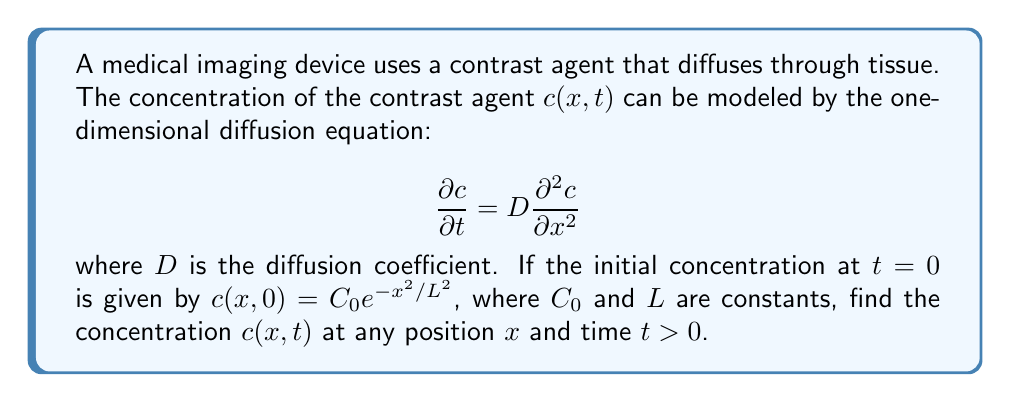Can you answer this question? To solve this problem, we'll follow these steps:

1) The general solution to the diffusion equation with an initial condition $c(x,0) = f(x)$ is:

   $$c(x,t) = \frac{1}{\sqrt{4\pi Dt}} \int_{-\infty}^{\infty} f(x') e^{-\frac{(x-x')^2}{4Dt}} dx'$$

2) In our case, $f(x) = C_0e^{-x^2/L^2}$. Substituting this into the general solution:

   $$c(x,t) = \frac{C_0}{\sqrt{4\pi Dt}} \int_{-\infty}^{\infty} e^{-x'^2/L^2} e^{-(x-x')^2/(4Dt)} dx'$$

3) To solve this integral, we need to complete the square in the exponent. Let's combine the exponents:

   $$\frac{-x'^2}{L^2} - \frac{(x-x')^2}{4Dt} = -\left(\frac{1}{L^2} + \frac{1}{4Dt}\right)x'^2 + \frac{x}{2Dt}x' - \frac{x^2}{4Dt}$$

4) Let $a = \frac{1}{L^2} + \frac{1}{4Dt}$ and $b = \frac{x}{2Dt}$. Then the exponent becomes:

   $$-ax'^2 + bx' - \frac{x^2}{4Dt} = -a\left(x'^2 - \frac{b}{a}x' + \frac{b^2}{4a^2}\right) + \frac{b^2}{4a} - \frac{x^2}{4Dt}$$

5) Substituting back and factoring out constants from the integral:

   $$c(x,t) = \frac{C_0}{\sqrt{4\pi Dt}} e^{-\frac{x^2}{4Dt}} e^{\frac{b^2}{4a}} \int_{-\infty}^{\infty} e^{-a(x'-\frac{b}{2a})^2} dx'$$

6) The integral $\int_{-\infty}^{\infty} e^{-a(x'-\frac{b}{2a})^2} dx' = \sqrt{\frac{\pi}{a}}$

7) Substituting this and simplifying:

   $$c(x,t) = \frac{C_0}{\sqrt{4\pi Dt}} e^{-\frac{x^2}{4Dt}} e^{\frac{b^2}{4a}} \sqrt{\frac{\pi}{a}} = \frac{C_0}{\sqrt{1 + 4Dt/L^2}} e^{-\frac{x^2}{4Dt + L^2}}$$

This is the final solution for $c(x,t)$.
Answer: $c(x,t) = \frac{C_0}{\sqrt{1 + 4Dt/L^2}} e^{-\frac{x^2}{4Dt + L^2}}$ 